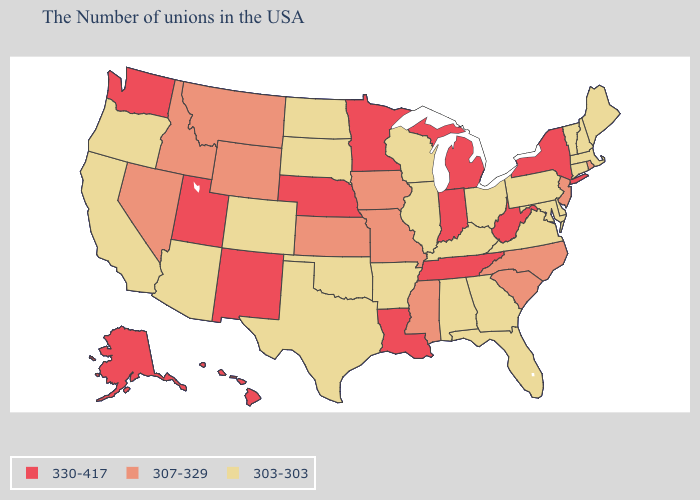Name the states that have a value in the range 330-417?
Quick response, please. New York, West Virginia, Michigan, Indiana, Tennessee, Louisiana, Minnesota, Nebraska, New Mexico, Utah, Washington, Alaska, Hawaii. Name the states that have a value in the range 307-329?
Be succinct. Rhode Island, New Jersey, North Carolina, South Carolina, Mississippi, Missouri, Iowa, Kansas, Wyoming, Montana, Idaho, Nevada. What is the highest value in the South ?
Quick response, please. 330-417. What is the value of New Mexico?
Be succinct. 330-417. What is the highest value in the USA?
Write a very short answer. 330-417. What is the value of Texas?
Answer briefly. 303-303. Does Alabama have the highest value in the USA?
Concise answer only. No. What is the highest value in the USA?
Keep it brief. 330-417. Which states have the highest value in the USA?
Quick response, please. New York, West Virginia, Michigan, Indiana, Tennessee, Louisiana, Minnesota, Nebraska, New Mexico, Utah, Washington, Alaska, Hawaii. What is the value of Minnesota?
Keep it brief. 330-417. What is the value of Pennsylvania?
Answer briefly. 303-303. What is the value of South Dakota?
Answer briefly. 303-303. Name the states that have a value in the range 303-303?
Concise answer only. Maine, Massachusetts, New Hampshire, Vermont, Connecticut, Delaware, Maryland, Pennsylvania, Virginia, Ohio, Florida, Georgia, Kentucky, Alabama, Wisconsin, Illinois, Arkansas, Oklahoma, Texas, South Dakota, North Dakota, Colorado, Arizona, California, Oregon. What is the highest value in the USA?
Keep it brief. 330-417. 